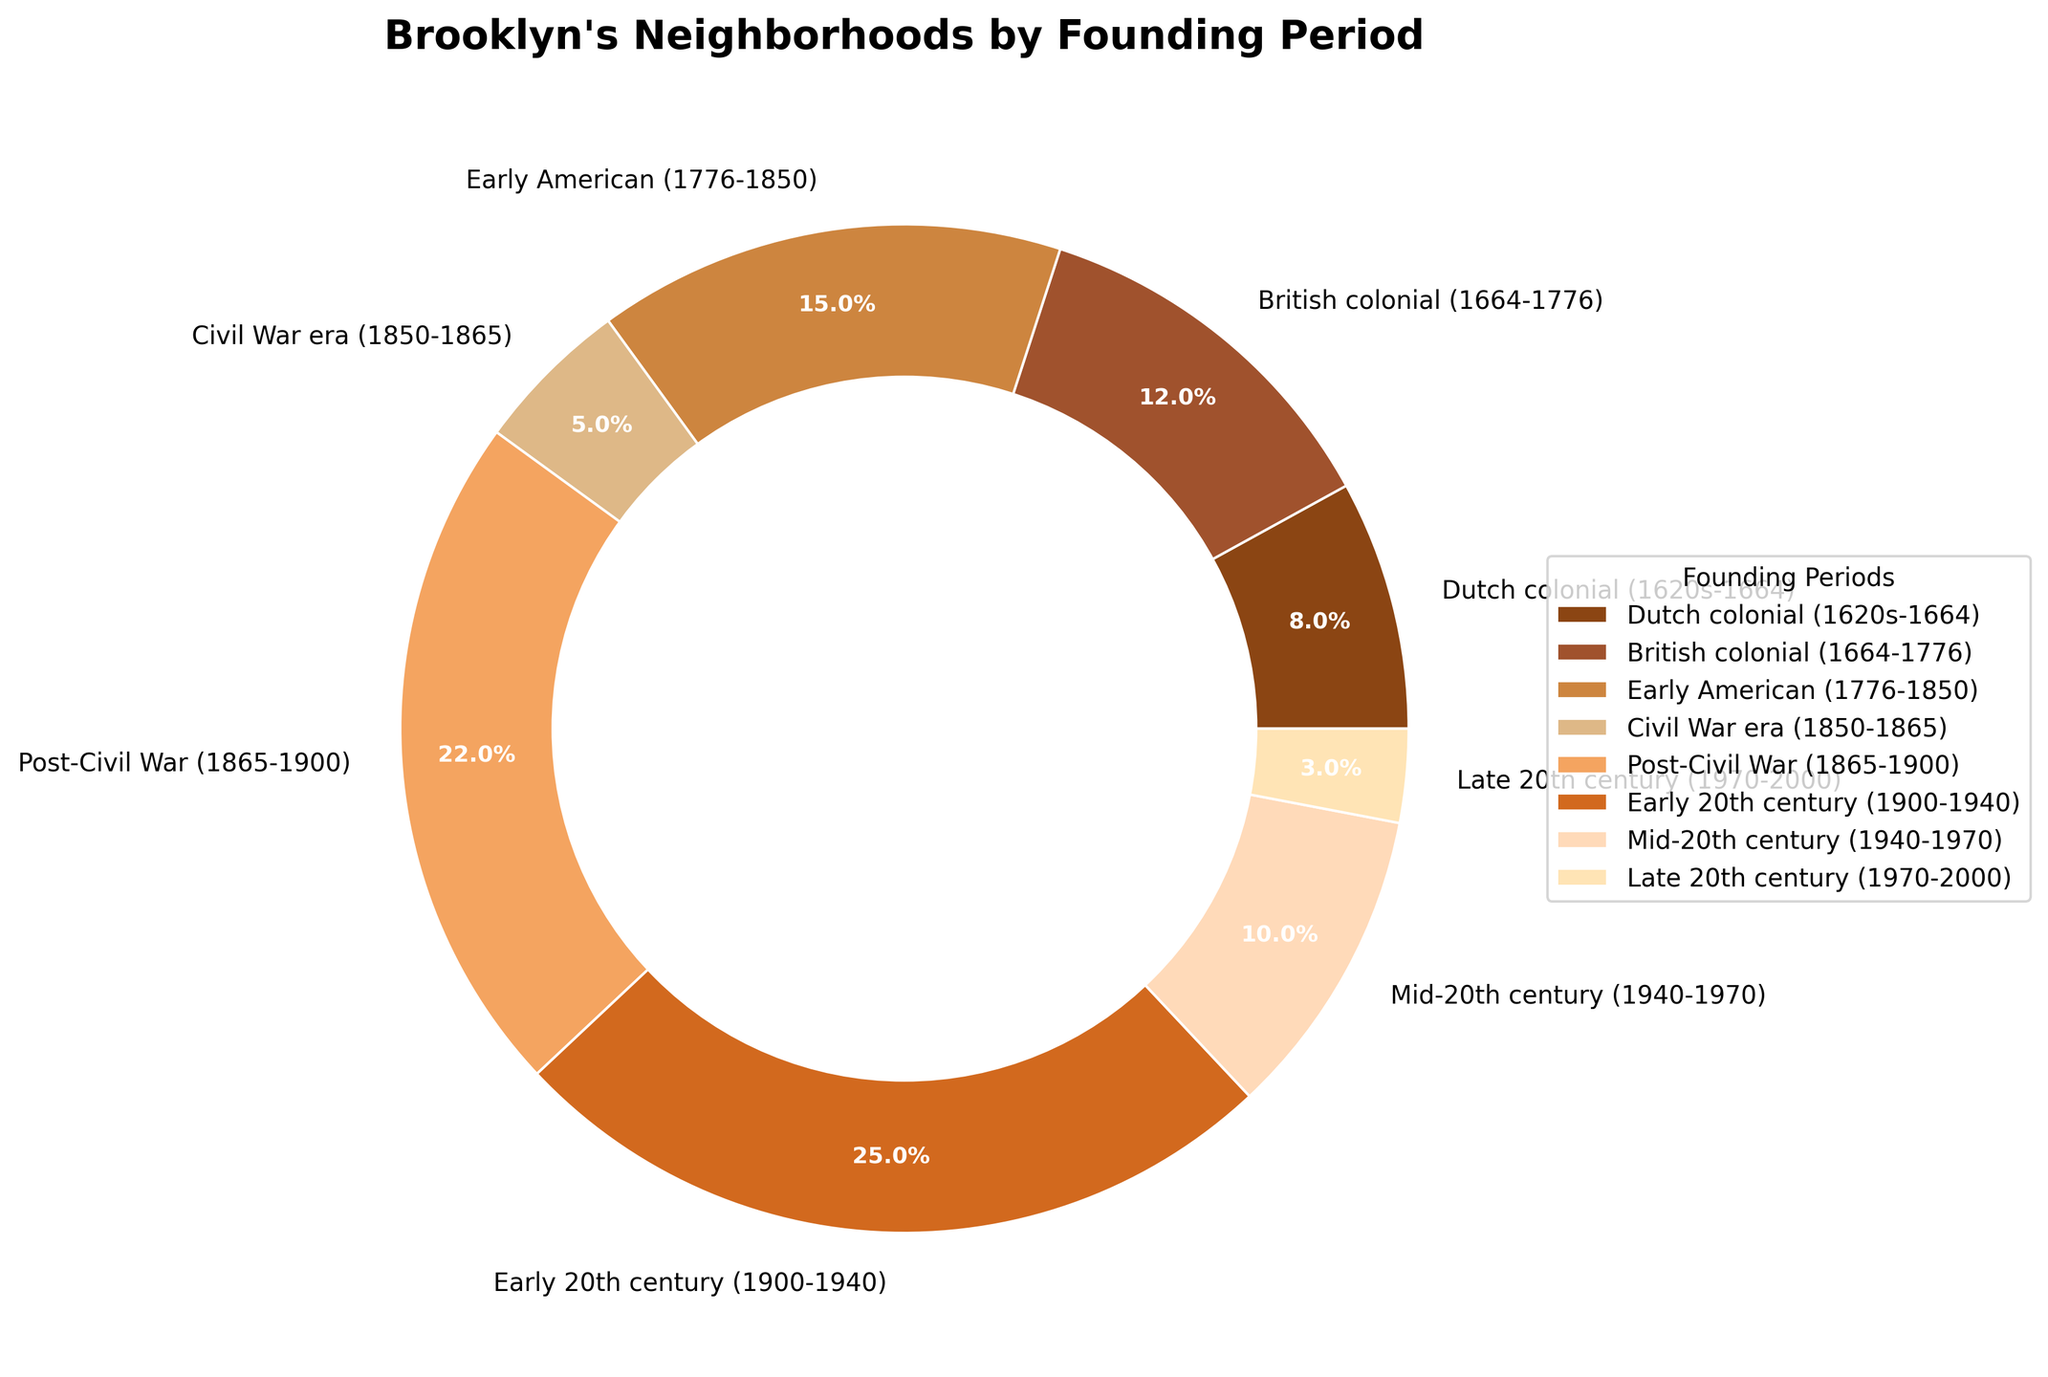Which founding period has the highest percentage of Brooklyn neighborhoods? Look at the figure and find the slice with the largest proportion. The "Early 20th century (1900-1940)" section has the largest percentage at 25%.
Answer: Early 20th century (1900-1940) Which founding period occupies the smallest section of the pie chart? Identify the smallest slice in the chart. The "Late 20th century (1970-2000)" section is the smallest at 3%.
Answer: Late 20th century (1970-2000) What is the combined percentage of neighborhoods founded during the 20th century (both 'Early 20th century' and 'Mid-20th century')? Add the percentages of both "Early 20th century (1900-1940)" and "Mid-20th century (1940-1970)" sections: 25% + 10% = 35%.
Answer: 35% How does the 'Dutch colonial' period compare to the 'British colonial' period in terms of the proportion of Brooklyn neighborhoods? Compare the "Dutch colonial (1620s-1664)" at 8% with the "British colonial (1664-1776)" at 12%. The British colonial period has a higher percentage.
Answer: The British colonial period has a higher percentage Is the percentage of neighborhoods founded in the 'Civil War era' greater than those founded in the 'Late 20th century'? Compare "Civil War era (1850-1865)" at 5% with "Late 20th century (1970-2000)" at 3%. The Civil War era has a greater percentage.
Answer: Yes, the Civil War era has a greater percentage What is the difference in percentage between neighborhoods founded in the 'Post-Civil War' and those in the 'Early American' periods? Subtract "Early American (1776-1850)" percentage (15%) from "Post-Civil War (1865-1900)" percentage (22%): 22% - 15% = 7%.
Answer: 7% What various shades of color represent the founding periods? Identify the colors used in the slices: brown shades for earlier periods and lighter shades for later periods, such as a deep brown for "Dutch colonial," lighter browns for "British colonial" to "Post-Civil War," and peach shades for "Early 20th century" onward.
Answer: Various shades of brown and peach Which period has a higher percentage, 'Early American' or 'Mid-20th century'? Compare "Early American (1776-1850)" at 15% with "Mid-20th century (1940-1970)" at 10%. "Early American" has a higher percentage.
Answer: Early American What is the total percentage of neighborhoods founded before the early 20th century ('Dutch colonial' to 'Post-Civil War')? Add the percentages of "Dutch colonial (1620s-1664)" 8%, "British colonial (1664-1776)" 12%, "Early American (1776-1850)" 15%, "Civil War era (1850-1865)" 5%, and "Post-Civil War (1865-1900)" 22%: 8% + 12% + 15% + 5% + 22% = 62%.
Answer: 62% How many founding periods have a percentage greater than 10%? Identify the slices with percentages above 10%: "British colonial," "Early American," "Post-Civil War," and "Early 20th century." There are 4 such periods.
Answer: 4 